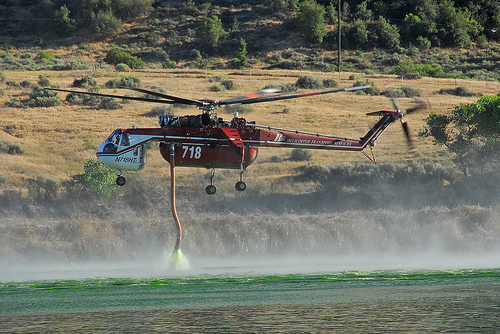<image>
Is there a helicopter in the field? No. The helicopter is not contained within the field. These objects have a different spatial relationship. 